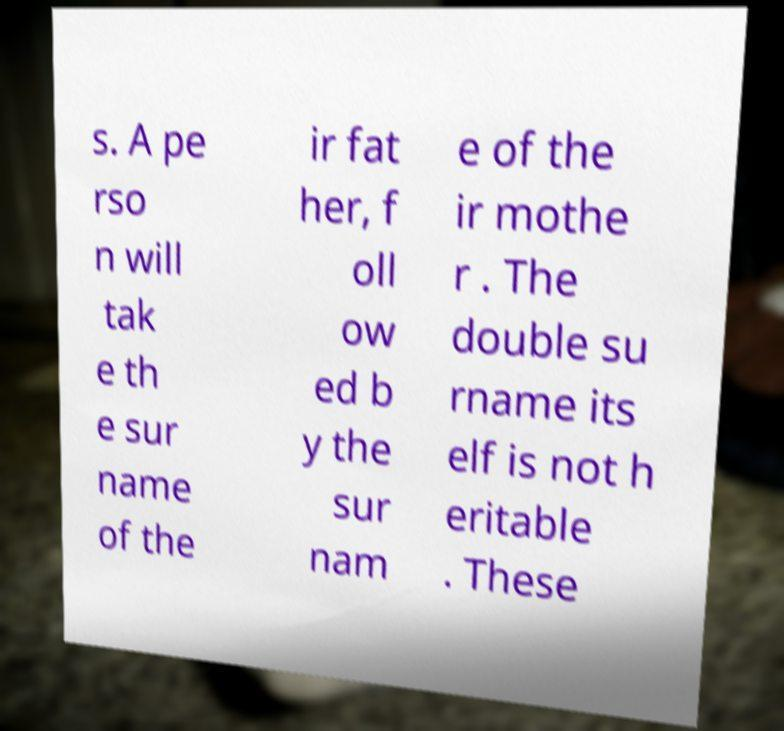For documentation purposes, I need the text within this image transcribed. Could you provide that? s. A pe rso n will tak e th e sur name of the ir fat her, f oll ow ed b y the sur nam e of the ir mothe r . The double su rname its elf is not h eritable . These 